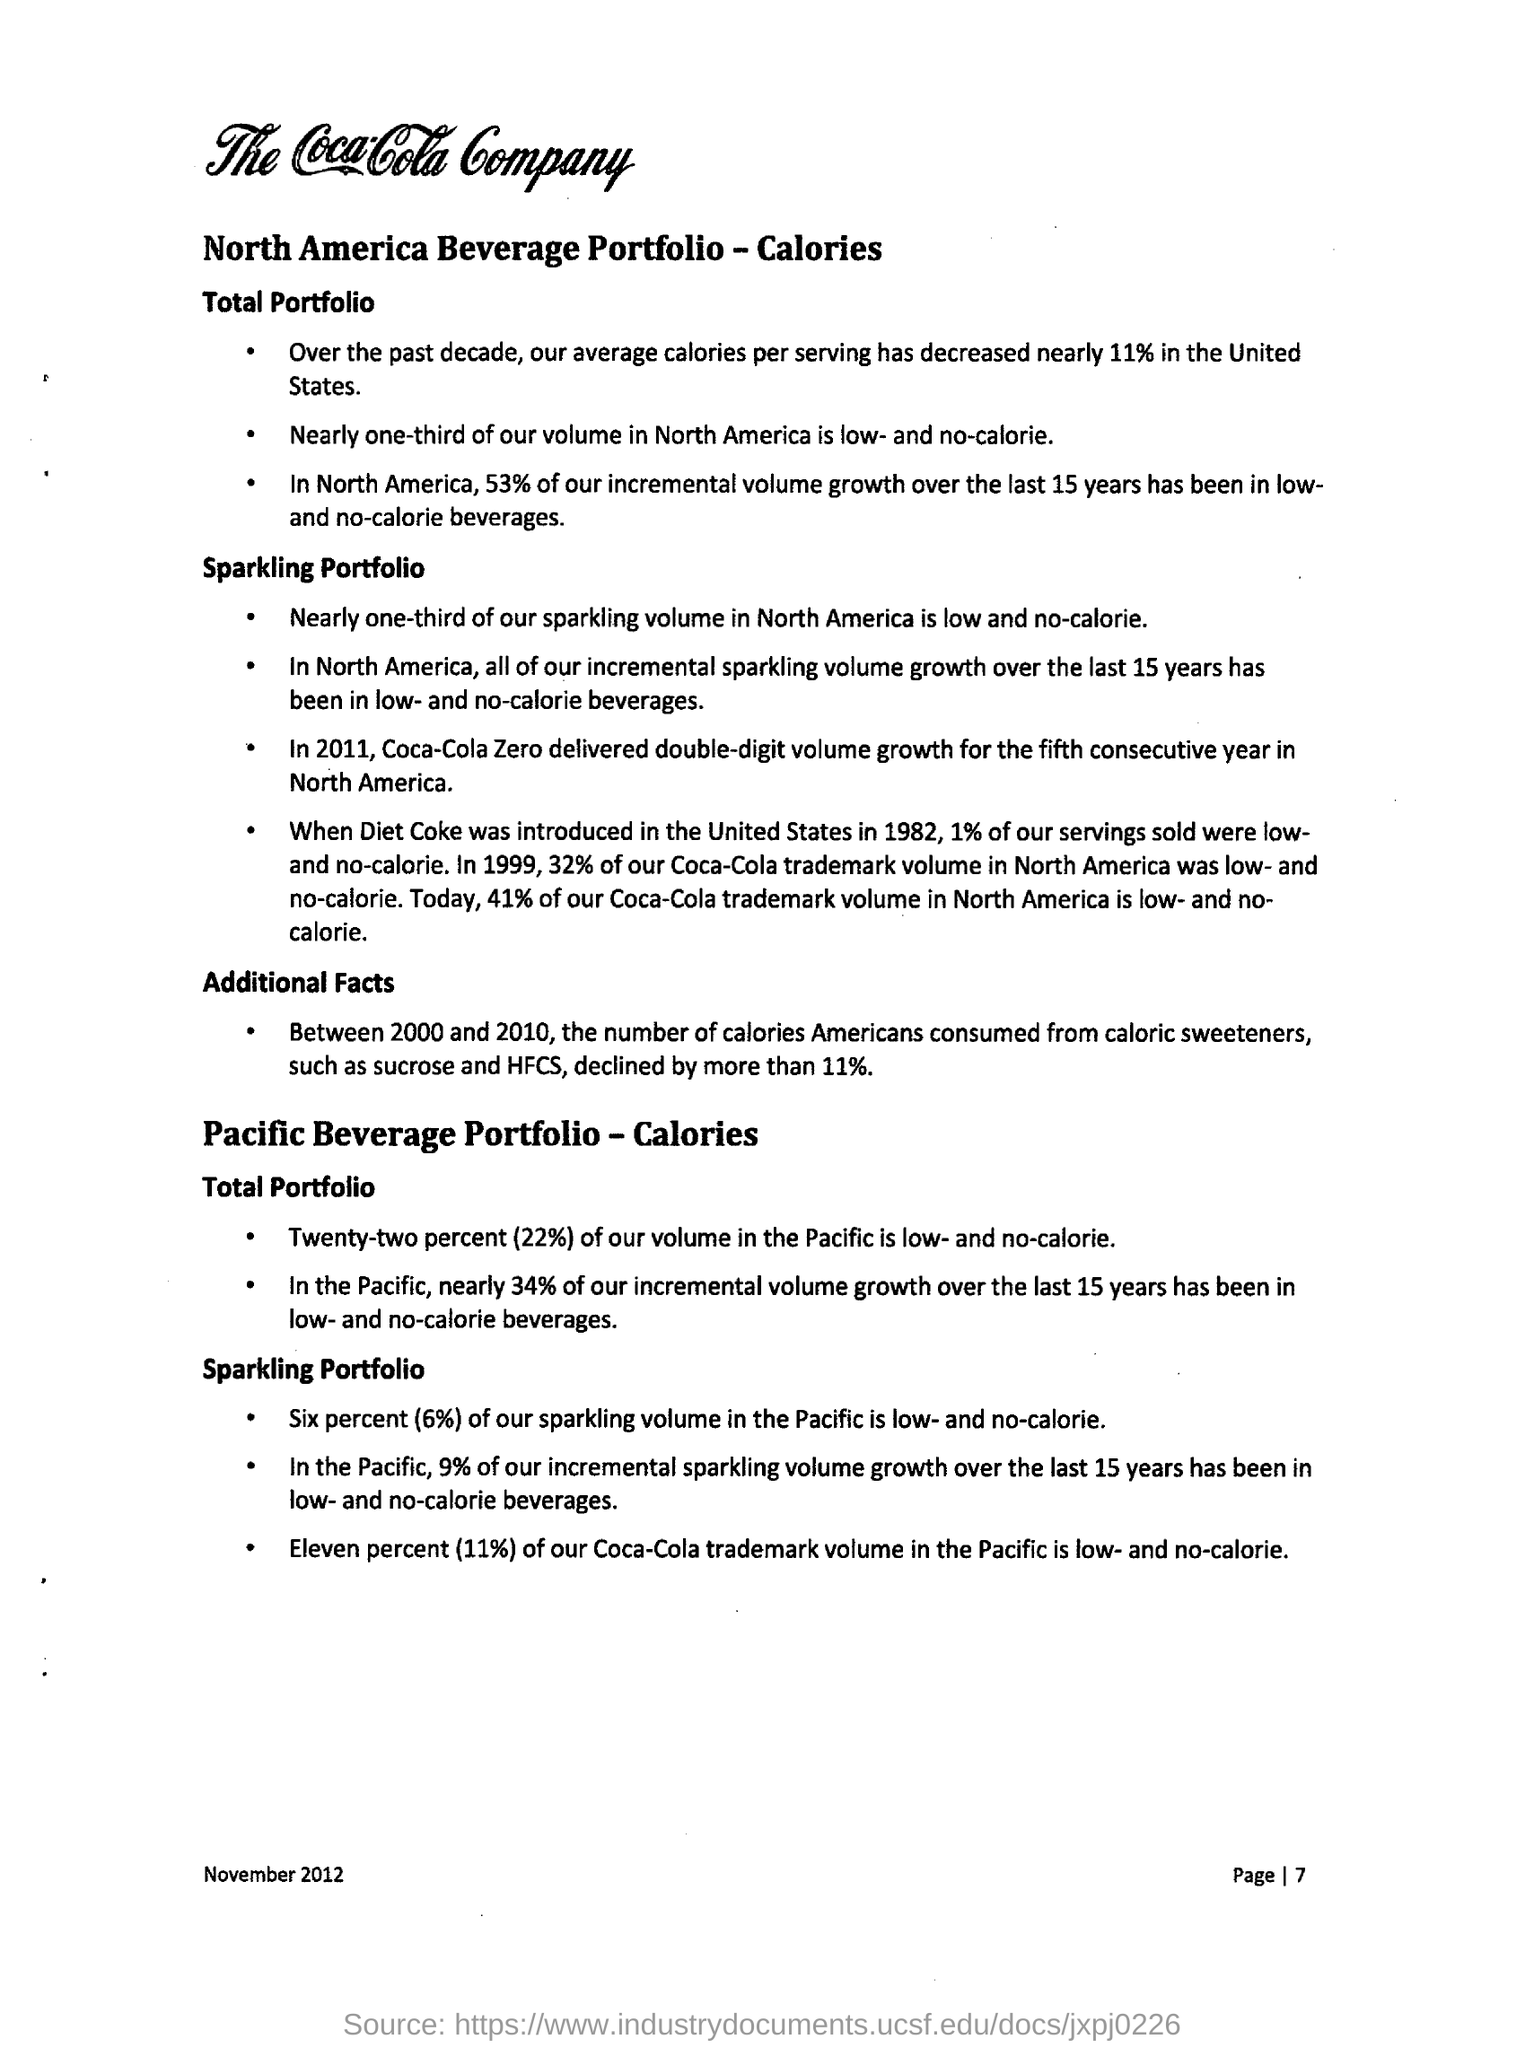Outline some significant characteristics in this image. In the United States, the average number of calories consumed per day has decreased by approximately 11% over the past decade. In 1982, Diet Coke was introduced in the United States. The number of calories Americans consumed from caloric sweeteners decreased by more than 11% between 2000 and 2010. 